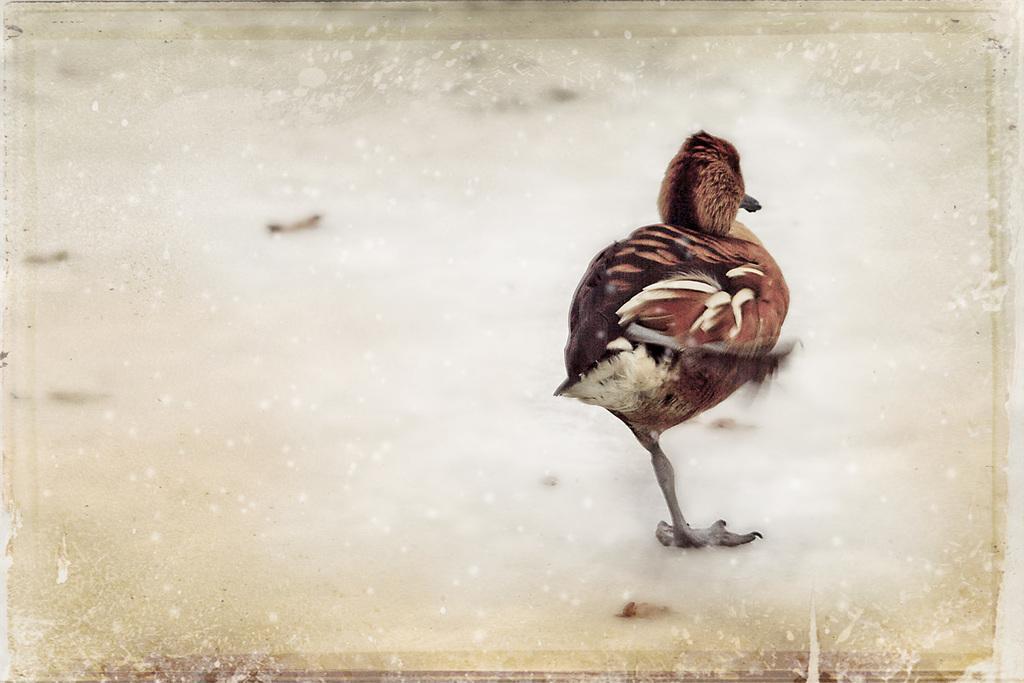Please provide a concise description of this image. In this image, we can see a bird and the ground. 